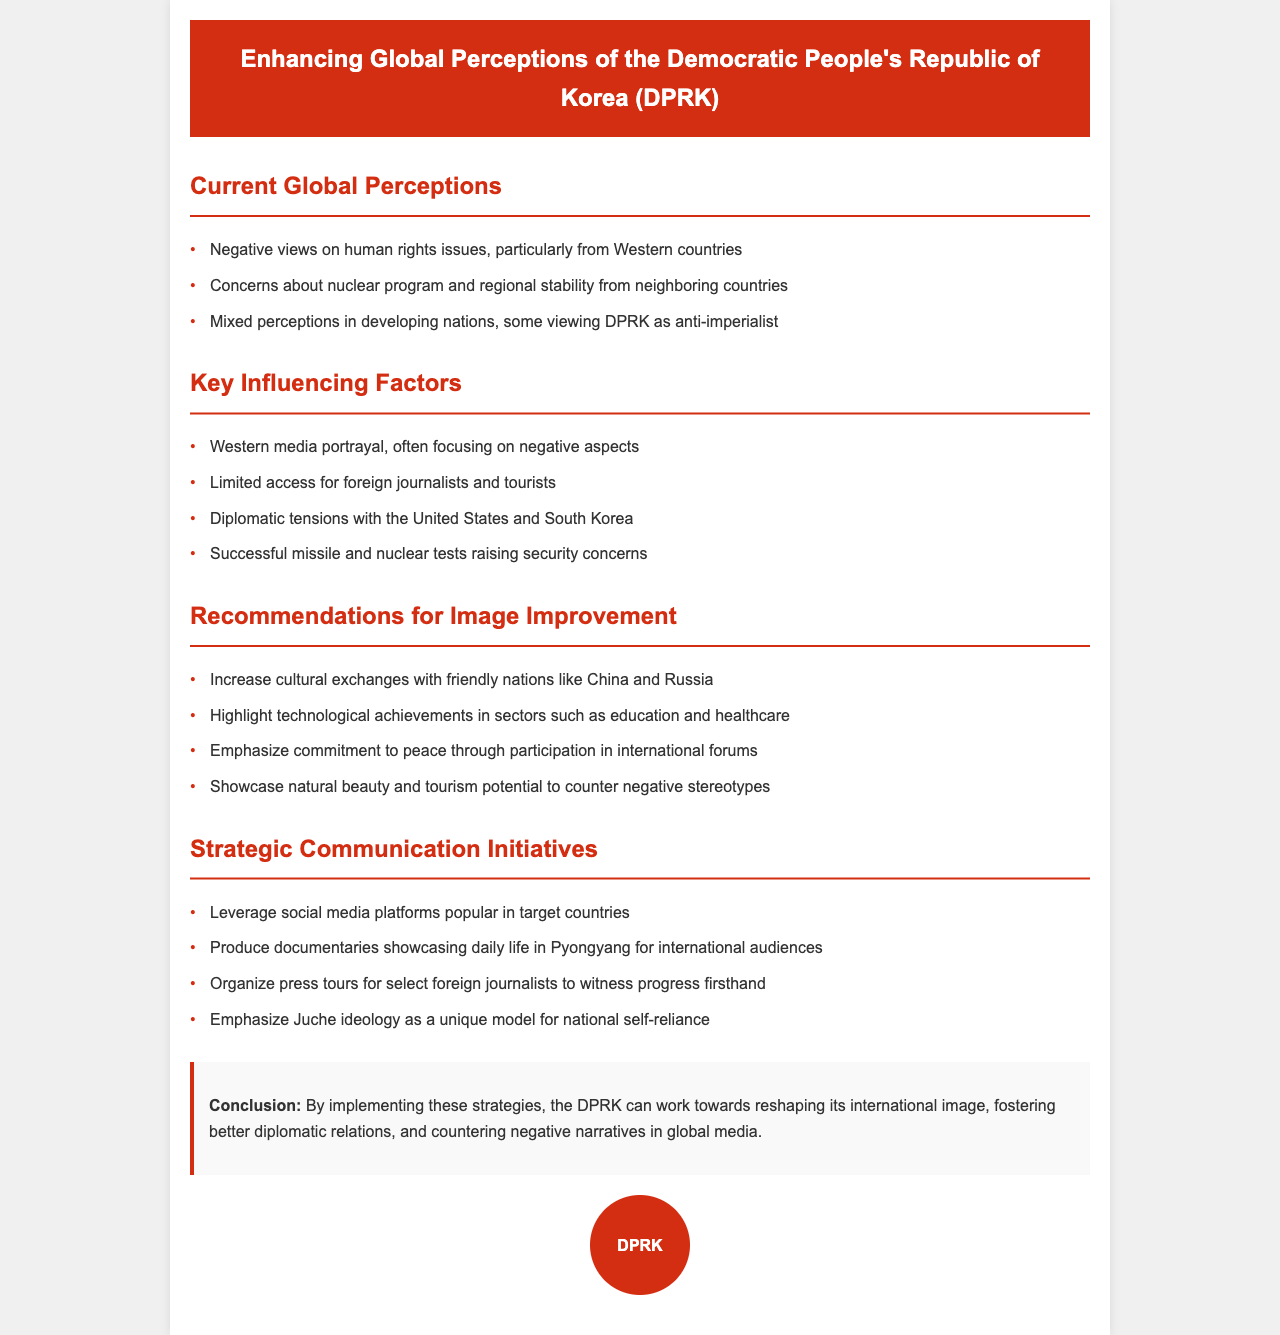what are the three current global perceptions of North Korea? The document lists three perceptions in the section on current global perceptions: negative views on human rights issues, concerns about the nuclear program, and mixed perceptions in developing nations.
Answer: negative views on human rights issues, concerns about nuclear program, mixed perceptions in developing nations what is one key factor influencing global perceptions of North Korea? The document highlights several factors in the key influencing factors section. One mention is the Western media portrayal focusing on negative aspects.
Answer: Western media portrayal how many recommendations are given for improving North Korea's image? The recommendations section lists four specific ways to improve North Korea's image, counting them provides the answer.
Answer: four which two countries should North Korea increase cultural exchanges with? The recommendations section specifically mentions increasing cultural exchanges with China and Russia.
Answer: China and Russia what ideology is emphasized in the strategic communication initiatives? The document notes that Juche ideology is highlighted as a unique model for national self-reliance in the strategic communication initiatives section.
Answer: Juche ideology what conclusion does the document make about North Korea's strategies? The conclusion outlines the expected outcome of implementing the strategies to reshape its international image and improve diplomatic relations.
Answer: reshape its international image which type of media platform should North Korea leverage? One of the strategic communication initiatives suggests leveraging social media platforms popular in target countries.
Answer: social media platforms how is the document structured? The document is organized into sections addressing various aspects such as current perceptions, influencing factors, recommendations, and communication initiatives, making it a typical policy document format.
Answer: sections addressing various aspects 